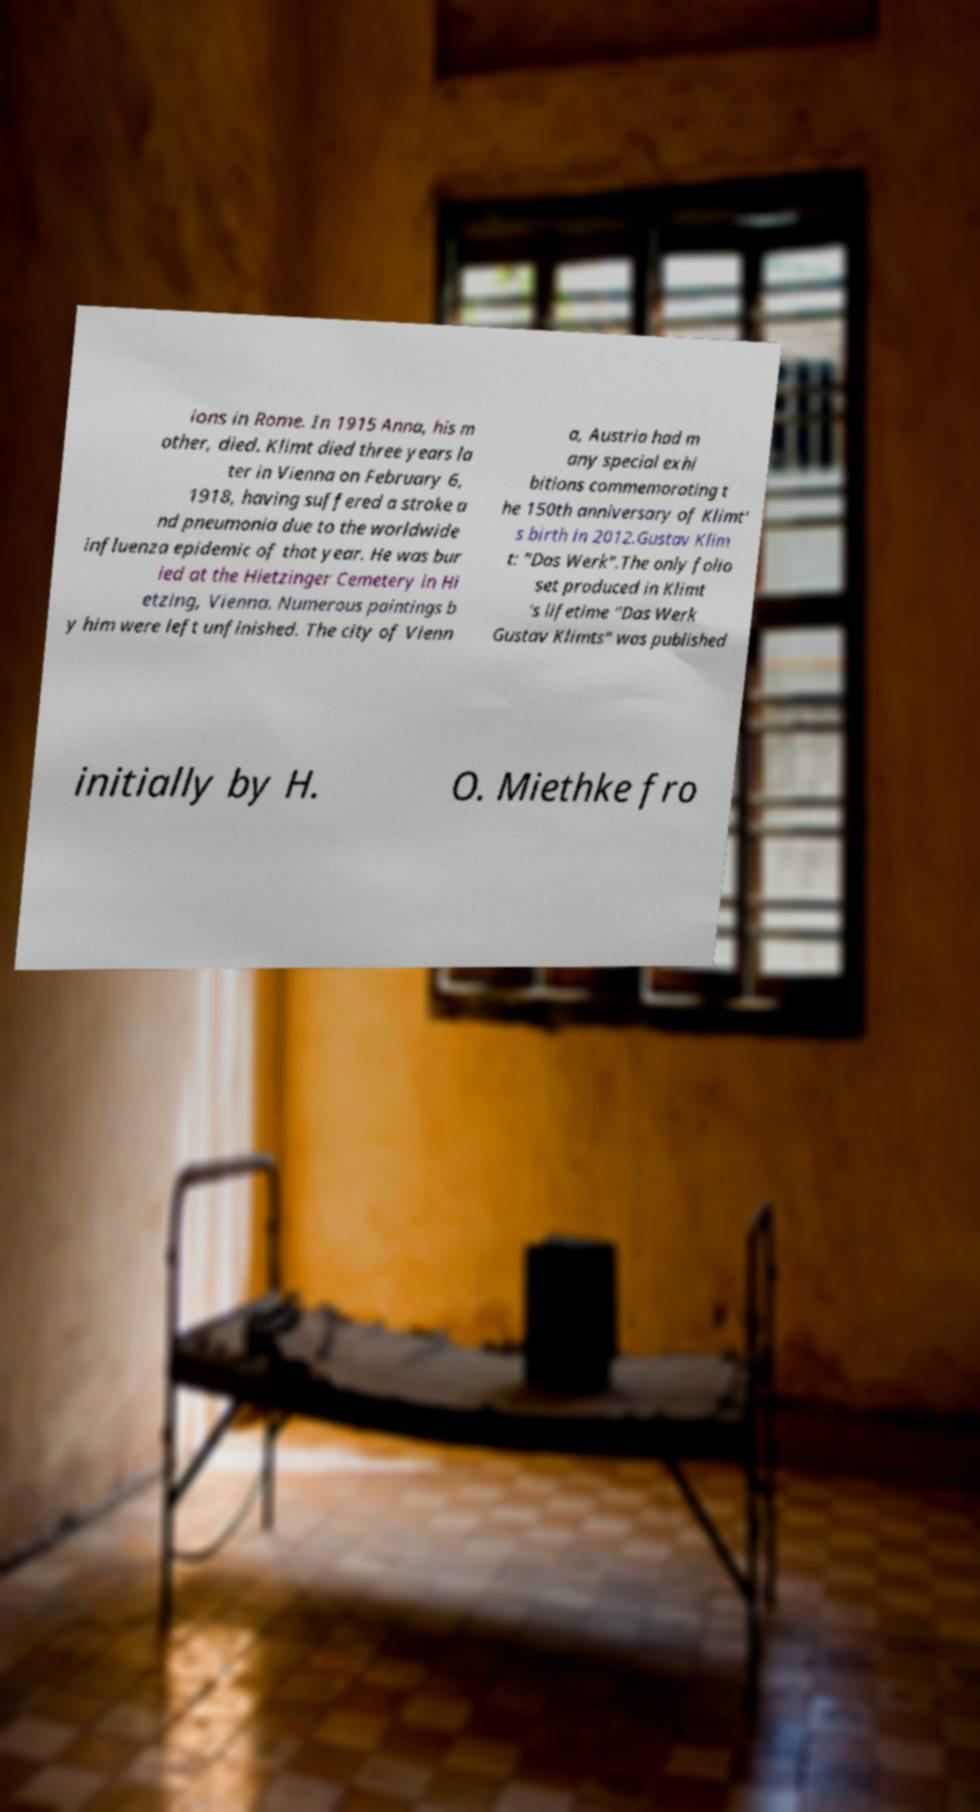Could you extract and type out the text from this image? ions in Rome. In 1915 Anna, his m other, died. Klimt died three years la ter in Vienna on February 6, 1918, having suffered a stroke a nd pneumonia due to the worldwide influenza epidemic of that year. He was bur ied at the Hietzinger Cemetery in Hi etzing, Vienna. Numerous paintings b y him were left unfinished. The city of Vienn a, Austria had m any special exhi bitions commemorating t he 150th anniversary of Klimt' s birth in 2012.Gustav Klim t: "Das Werk".The only folio set produced in Klimt 's lifetime "Das Werk Gustav Klimts" was published initially by H. O. Miethke fro 